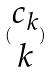<formula> <loc_0><loc_0><loc_500><loc_500>( \begin{matrix} c _ { k } \\ k \end{matrix} )</formula> 